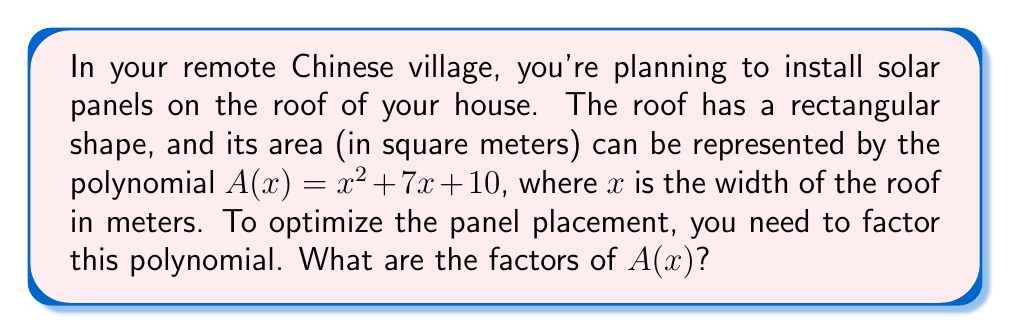Give your solution to this math problem. Let's factor the polynomial $A(x) = x^2 + 7x + 10$ step-by-step:

1) First, we recognize this as a quadratic polynomial in the form $ax^2 + bx + c$, where $a=1$, $b=7$, and $c=10$.

2) To factor this, we need to find two numbers that multiply to give $ac$ (which is 1 * 10 = 10) and add up to $b$ (which is 7).

3) The two numbers that satisfy this are 2 and 5, because:
   $2 * 5 = 10$ and $2 + 5 = 7$

4) We can rewrite the middle term using these numbers:
   $A(x) = x^2 + 2x + 5x + 10$

5) Now we can factor by grouping:
   $A(x) = (x^2 + 2x) + (5x + 10)$
   $A(x) = x(x + 2) + 5(x + 2)$
   $A(x) = (x + 5)(x + 2)$

6) Therefore, the factors of $A(x)$ are $(x + 5)$ and $(x + 2)$.

This factorization can help optimize solar panel placement by identifying the dimensions that make up the roof area.
Answer: $(x + 5)(x + 2)$ 